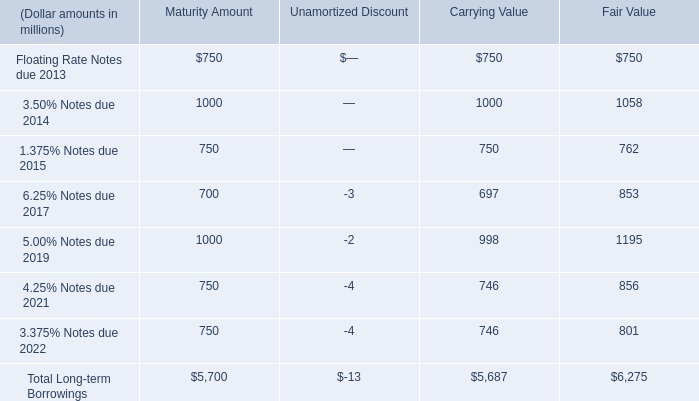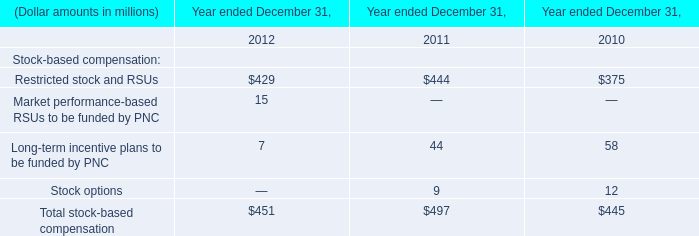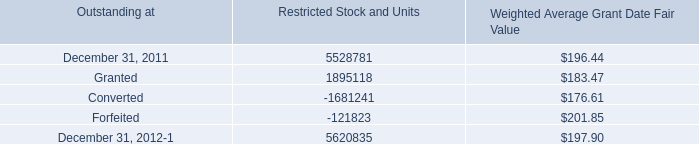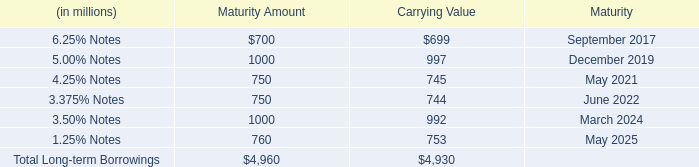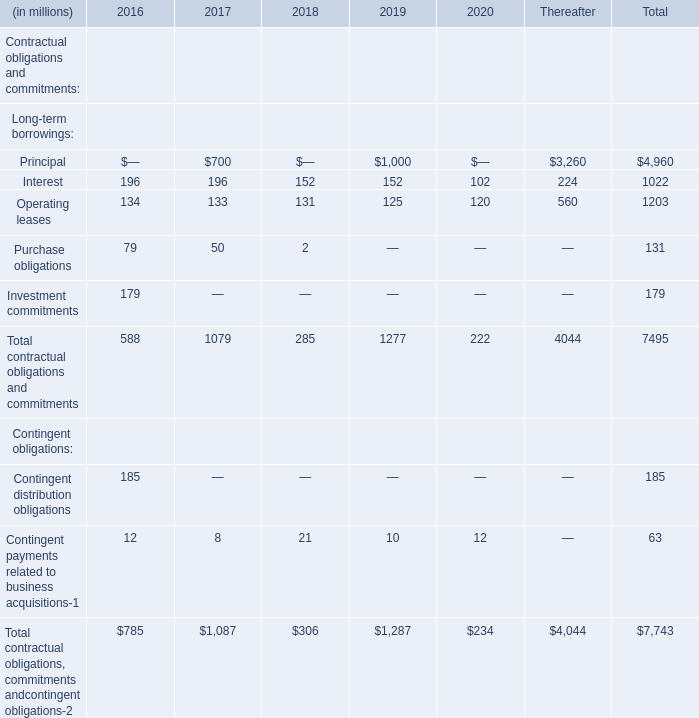What's the difference of Interest between 2017 and 2018? (in million) 
Computations: (196 - 152)
Answer: 44.0. 